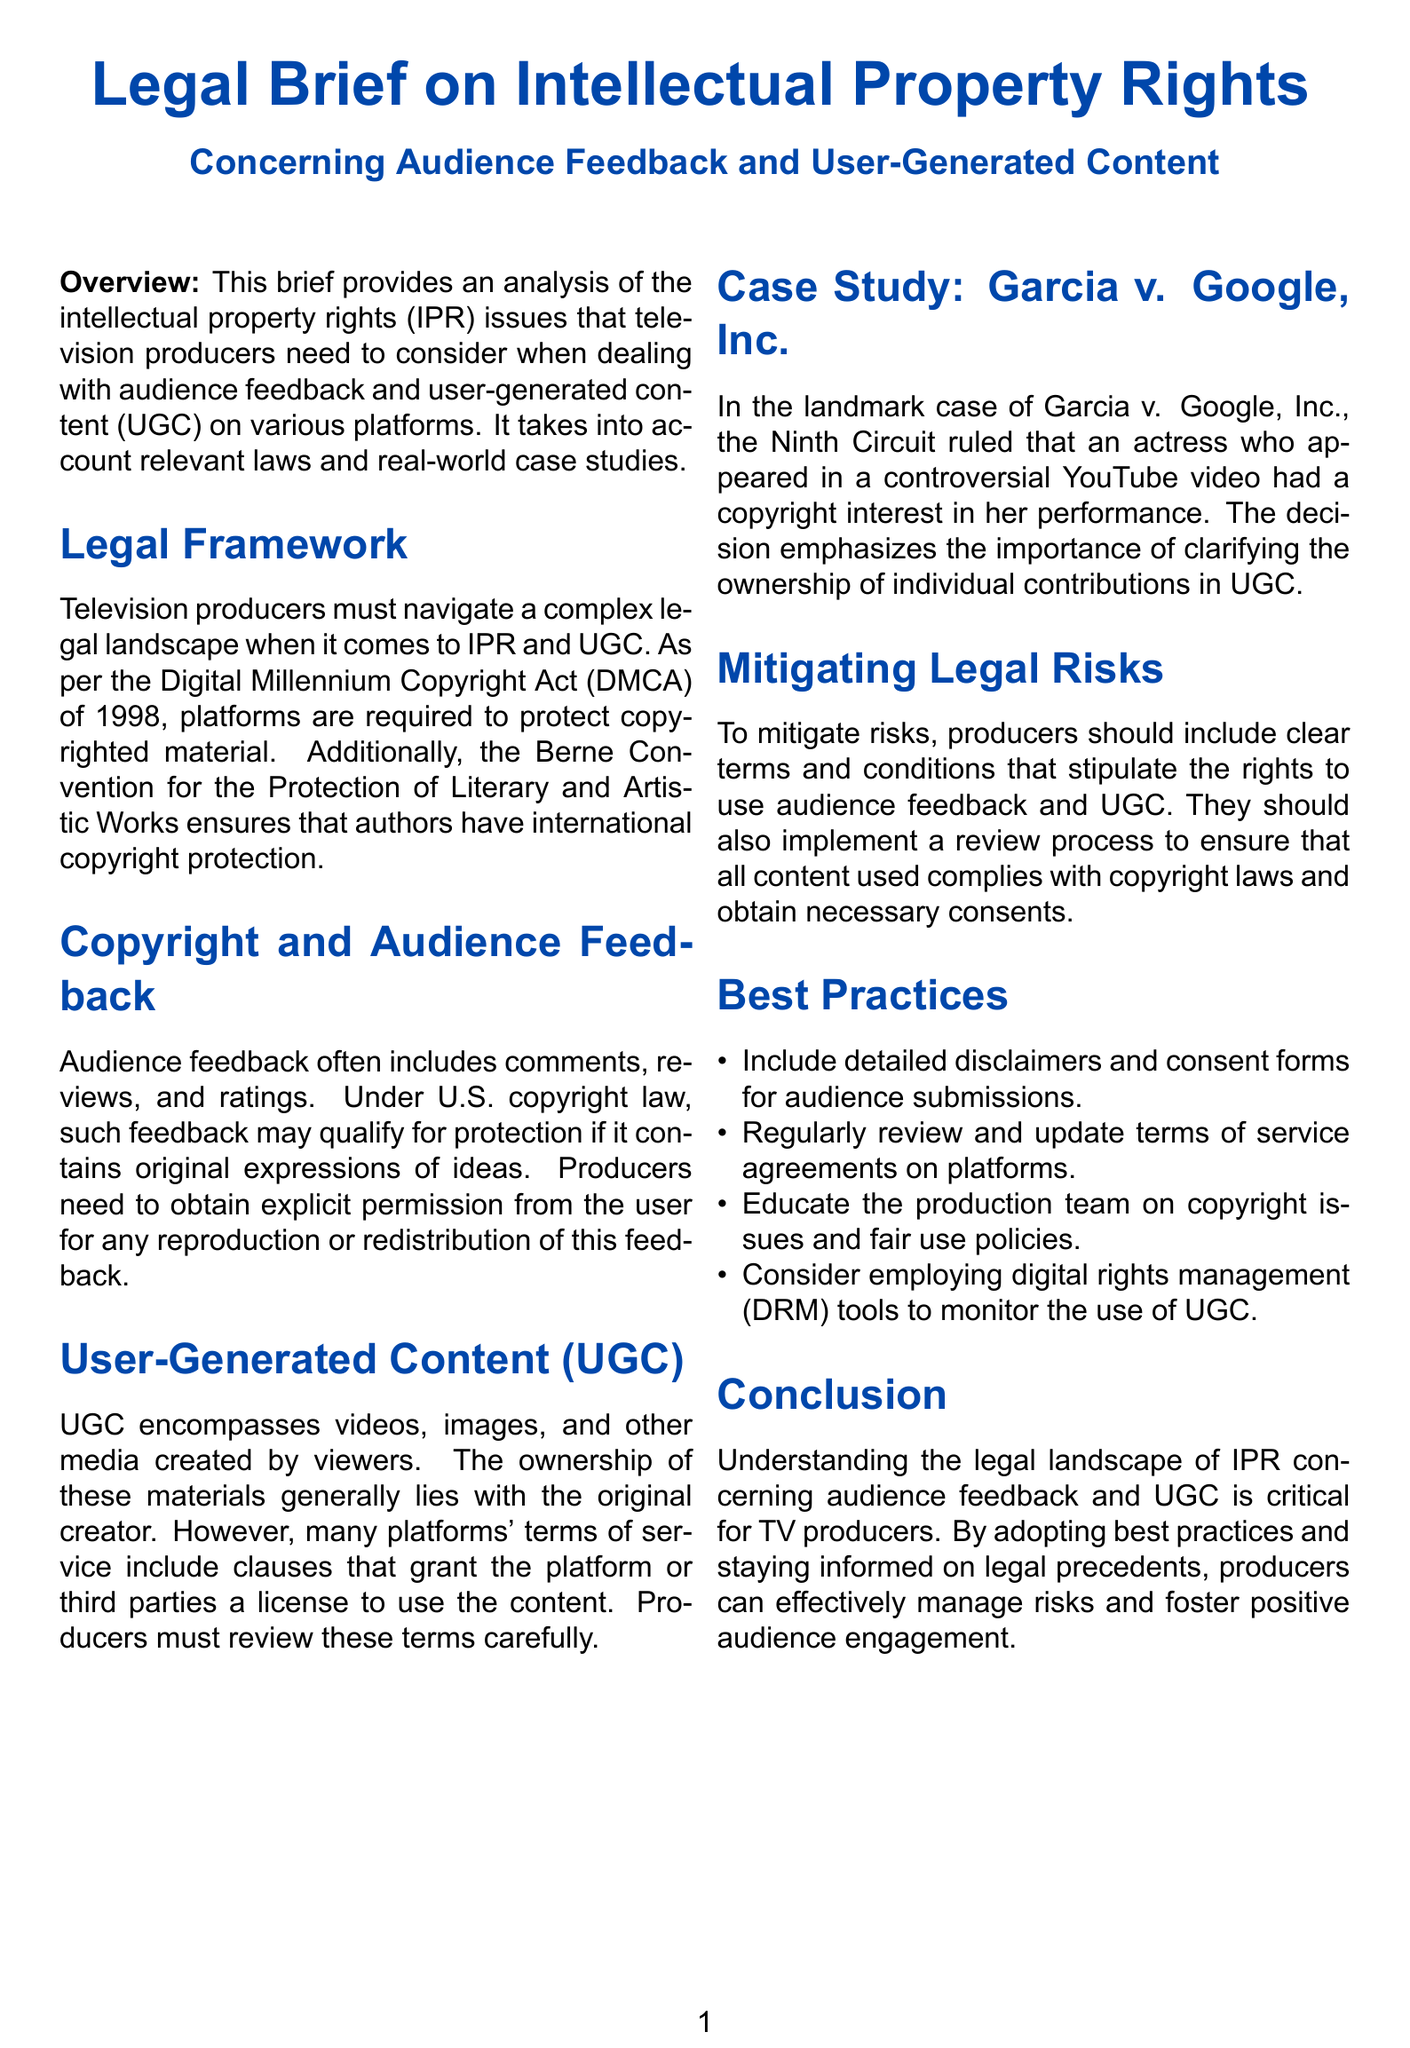What legal act requires platforms to protect copyrighted material? The document mentions the Digital Millennium Copyright Act (DMCA) as the legal act that requires this protection.
Answer: Digital Millennium Copyright Act (DMCA) What is necessary for producers to use audience feedback? The document states that producers need to obtain explicit permission from the user for any reproduction or redistribution of feedback.
Answer: Explicit permission Which convention provides international copyright protection to authors? The document refers to the Berne Convention for the Protection of Literary and Artistic Works as the source of this protection.
Answer: Berne Convention In which case did the Ninth Circuit emphasize ownership in UGC? The document cites the case of Garcia v. Google, Inc. as emphasizing the importance of ownership in user-generated content.
Answer: Garcia v. Google, Inc What should producers include to mitigate legal risks associated with UGC? The document suggests that producers should include clear terms and conditions that stipulate rights to use audience feedback and UGC.
Answer: Clear terms and conditions What is a best practice for handling audience submissions mentioned in the document? The document lists including detailed disclaimers and consent forms for audience submissions as a best practice.
Answer: Detailed disclaimers and consent forms How should producers educate their teams regarding copyright issues? The document suggests that producers should educate the production team on copyright issues and fair use policies.
Answer: Copyright issues and fair use policies What tool can be employed to monitor the use of UGC? The document mentions that producers should consider employing digital rights management (DRM) tools for this purpose.
Answer: Digital rights management (DRM) tools 